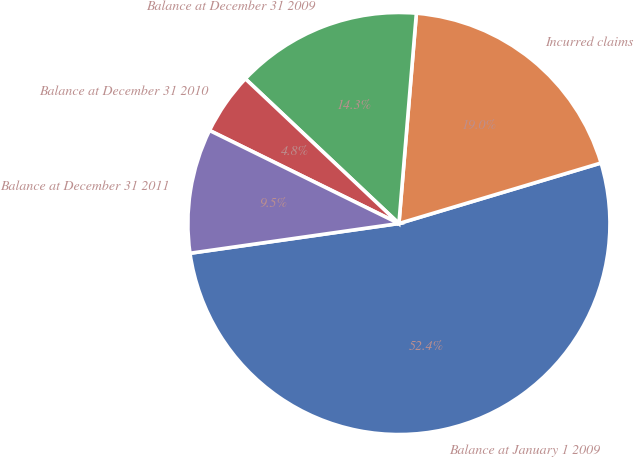Convert chart to OTSL. <chart><loc_0><loc_0><loc_500><loc_500><pie_chart><fcel>Balance at January 1 2009<fcel>Incurred claims<fcel>Balance at December 31 2009<fcel>Balance at December 31 2010<fcel>Balance at December 31 2011<nl><fcel>52.38%<fcel>19.05%<fcel>14.29%<fcel>4.76%<fcel>9.52%<nl></chart> 